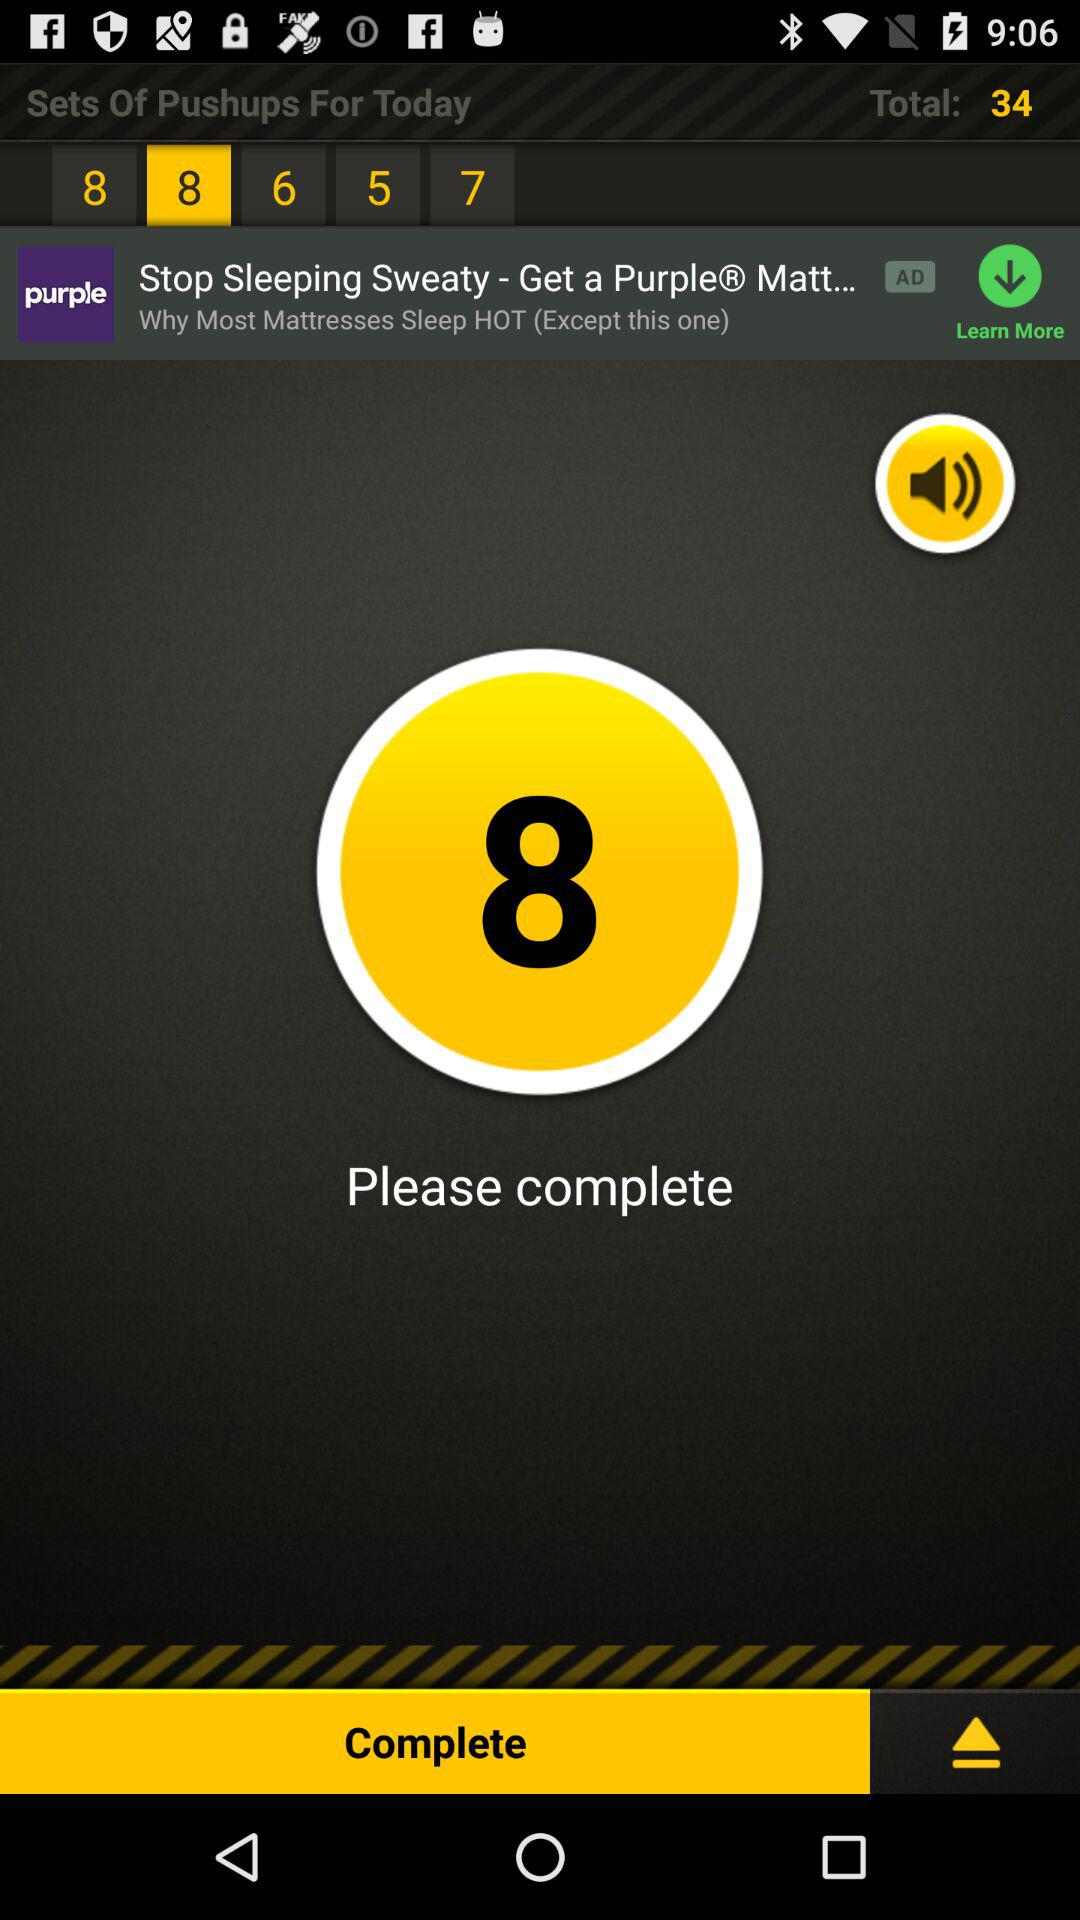How many more pushups do I need to do to reach my goal?
Answer the question using a single word or phrase. 34 